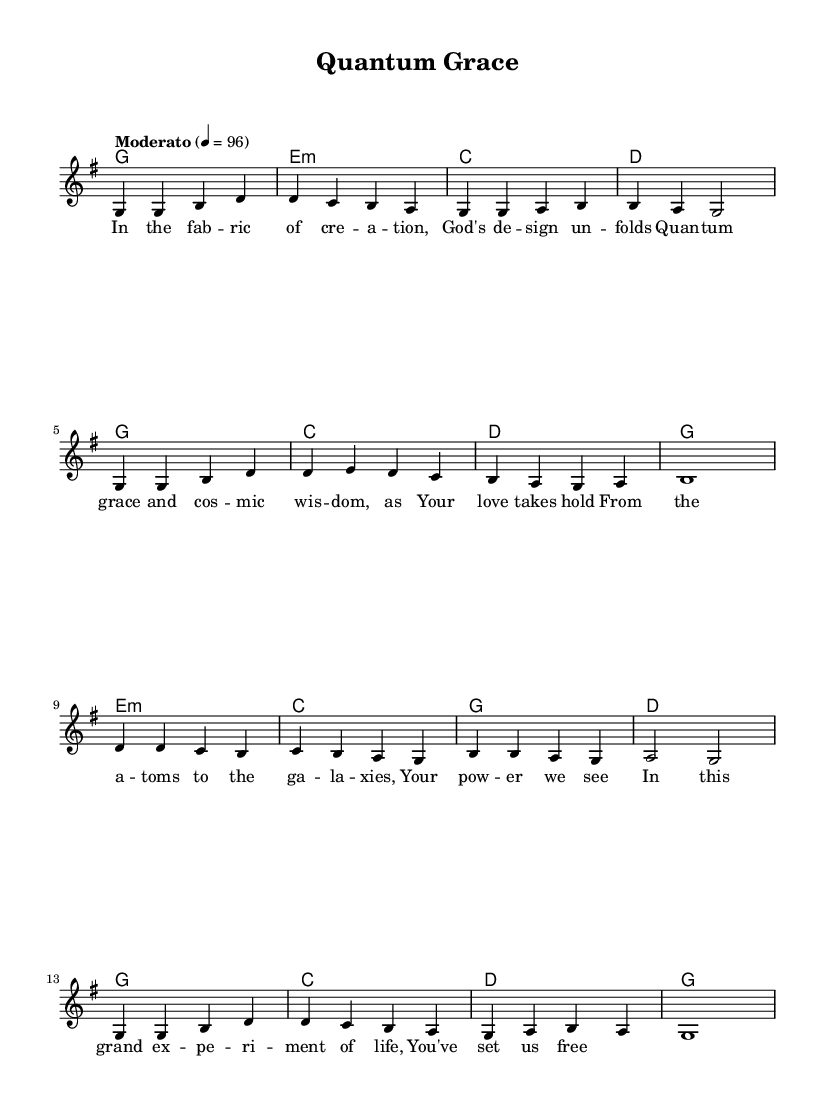What is the key signature of this music? The key signature is G major, which has one sharp (F#). This can be determined by looking at the top of the sheet music where the key signature is indicated.
Answer: G major What is the time signature of this music? The time signature is 4/4, which means there are four beats per measure and the quarter note gets one beat. This can be identified from the time signature notation located at the beginning of the staff.
Answer: 4/4 What is the tempo marking of this piece? The tempo marking is "Moderato" with a metronome mark of 96 beats per minute. This is indicated near the beginning of the score where tempo is specified.
Answer: Moderato How many measures are in the melody? The melody consists of 16 measures. This can be counted by looking at how the melody is divided across the staff lines and how many vertical lines (barlines) are present.
Answer: 16 What is the first lyric line of the song? The first lyric line is "In the fab -- ric of cre -- a -- tion." This can be found directly beneath the melody notes where the lyrics are printed aligning with the corresponding notes.
Answer: In the fab -- ric of cre -- a -- tion Which chord follows the initial G major chord? The chord that follows the initial G major chord is E minor. This can be determined by looking closely at the chord progression indicated above the staff, following the G major (g1) at the start.
Answer: E minor What theme is reflected in the lyrics of this song? The theme reflected in the lyrics is creation and God's power. This can be inferred from phrases discussing creation, atoms, galaxies, and divine wisdom present in the lyrics.
Answer: Creation and God's power 